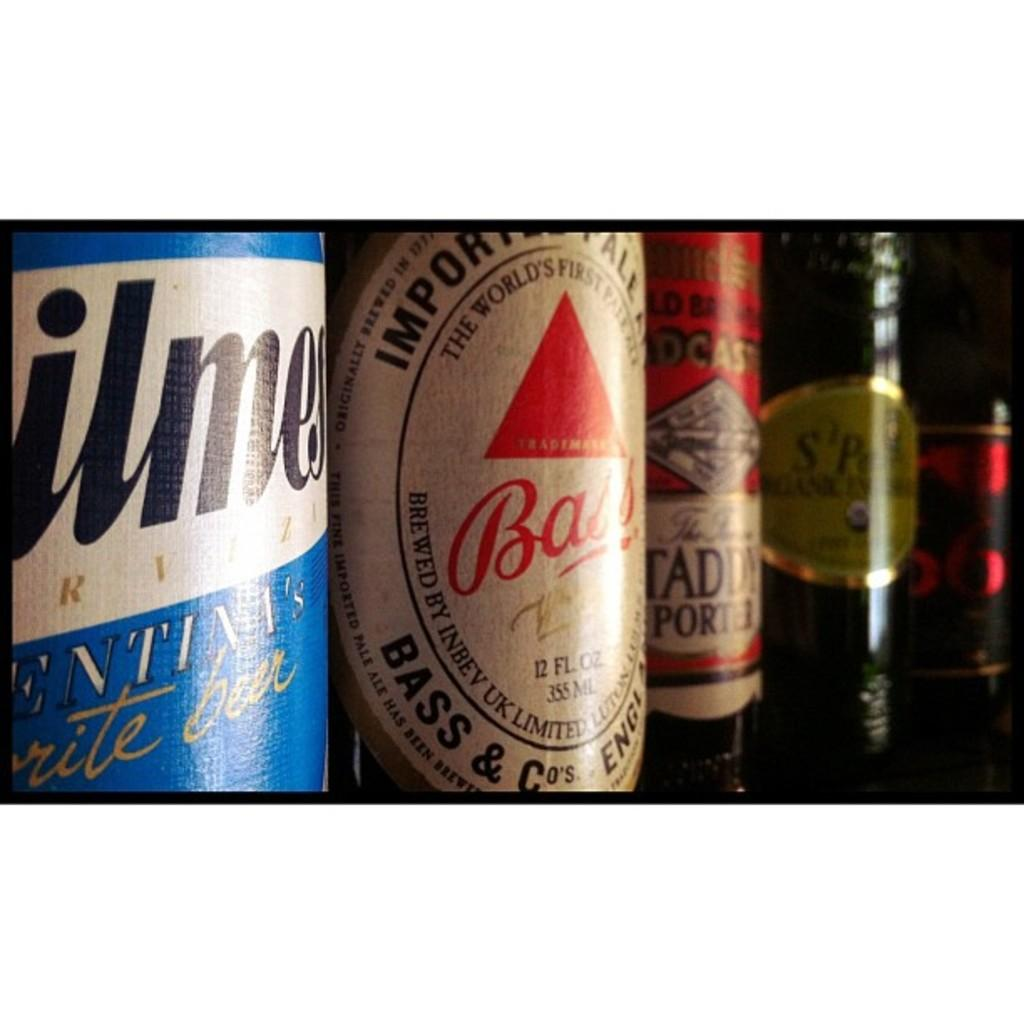<image>
Write a terse but informative summary of the picture. the word bass that is on a bottle of beer 